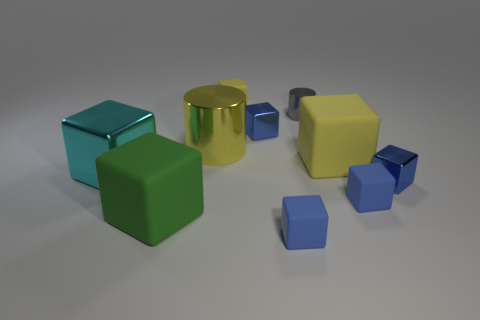How many small metal cubes are both right of the tiny gray metal cylinder and to the left of the big yellow matte object?
Keep it short and to the point. 0. Is the tiny metal cylinder the same color as the large shiny cube?
Give a very brief answer. No. There is a big green object that is the same shape as the cyan shiny thing; what is it made of?
Your answer should be compact. Rubber. Are there any other things that are the same material as the tiny gray cylinder?
Give a very brief answer. Yes. Are there the same number of large yellow rubber things that are to the left of the tiny cylinder and tiny blue cubes behind the green cube?
Your answer should be very brief. No. Do the big cyan block and the tiny gray cylinder have the same material?
Offer a terse response. Yes. What number of gray things are either big metal blocks or big cylinders?
Your answer should be very brief. 0. How many small shiny objects are the same shape as the large green matte thing?
Offer a very short reply. 2. What material is the tiny yellow cube?
Ensure brevity in your answer.  Rubber. Are there the same number of small blue metallic blocks behind the big metal cylinder and small purple metallic blocks?
Your response must be concise. No. 